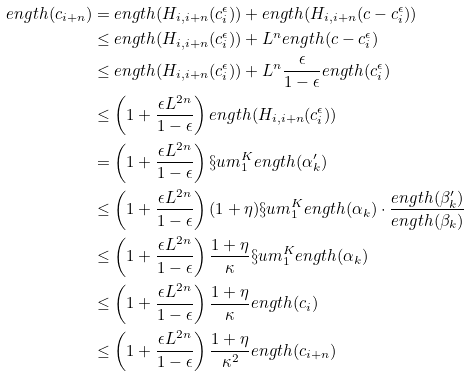Convert formula to latex. <formula><loc_0><loc_0><loc_500><loc_500>\L e n g t h ( c _ { i + n } ) & = \L e n g t h ( H _ { i , i + n } ( c ^ { \epsilon } _ { i } ) ) + \L e n g t h ( H _ { i , i + n } ( c - c ^ { \epsilon } _ { i } ) ) \\ & \leq \L e n g t h ( H _ { i , i + n } ( c ^ { \epsilon } _ { i } ) ) + L ^ { n } \L e n g t h ( c - c ^ { \epsilon } _ { i } ) \\ & \leq \L e n g t h ( H _ { i , i + n } ( c ^ { \epsilon } _ { i } ) ) + L ^ { n } \frac { \epsilon } { 1 - \epsilon } \L e n g t h ( c ^ { \epsilon } _ { i } ) \\ & \leq \left ( 1 + \frac { \epsilon L ^ { 2 n } } { 1 - \epsilon } \right ) \L e n g t h ( H _ { i , i + n } ( c ^ { \epsilon } _ { i } ) ) \\ & = \left ( 1 + \frac { \epsilon L ^ { 2 n } } { 1 - \epsilon } \right ) \S u m _ { 1 } ^ { K } \L e n g t h ( \alpha ^ { \prime } _ { k } ) \\ & \leq \left ( 1 + \frac { \epsilon L ^ { 2 n } } { 1 - \epsilon } \right ) ( 1 + \eta ) \S u m _ { 1 } ^ { K } \L e n g t h ( \alpha _ { k } ) \cdot \frac { \L e n g t h ( \beta ^ { \prime } _ { k } ) } { \L e n g t h ( \beta _ { k } ) } \\ & \leq \left ( 1 + \frac { \epsilon L ^ { 2 n } } { 1 - \epsilon } \right ) \frac { 1 + \eta } { \kappa } \S u m _ { 1 } ^ { K } \L e n g t h ( \alpha _ { k } ) \\ & \leq \left ( 1 + \frac { \epsilon L ^ { 2 n } } { 1 - \epsilon } \right ) \frac { 1 + \eta } { \kappa } \L e n g t h ( c _ { i } ) \\ & \leq \left ( 1 + \frac { \epsilon L ^ { 2 n } } { 1 - \epsilon } \right ) \frac { 1 + \eta } { \kappa ^ { 2 } } \L e n g t h ( c _ { i + n } )</formula> 